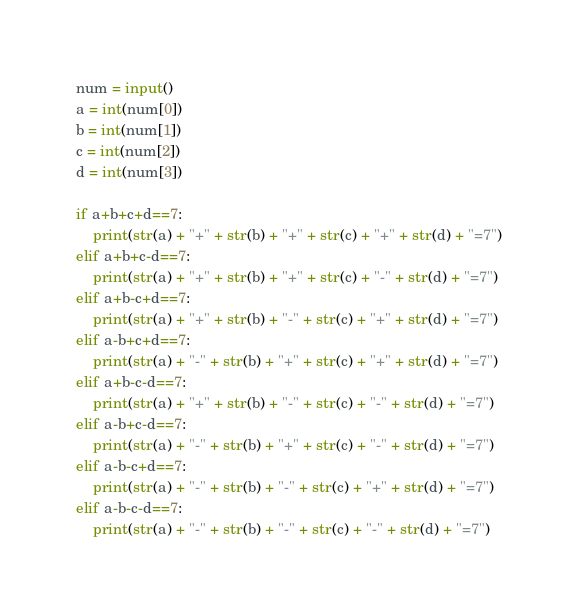<code> <loc_0><loc_0><loc_500><loc_500><_Python_>num = input()
a = int(num[0])
b = int(num[1])
c = int(num[2])
d = int(num[3])

if a+b+c+d==7:
    print(str(a) + "+" + str(b) + "+" + str(c) + "+" + str(d) + "=7")
elif a+b+c-d==7:
    print(str(a) + "+" + str(b) + "+" + str(c) + "-" + str(d) + "=7")
elif a+b-c+d==7:
    print(str(a) + "+" + str(b) + "-" + str(c) + "+" + str(d) + "=7")
elif a-b+c+d==7:
    print(str(a) + "-" + str(b) + "+" + str(c) + "+" + str(d) + "=7")
elif a+b-c-d==7:
    print(str(a) + "+" + str(b) + "-" + str(c) + "-" + str(d) + "=7")
elif a-b+c-d==7:
    print(str(a) + "-" + str(b) + "+" + str(c) + "-" + str(d) + "=7")
elif a-b-c+d==7:
    print(str(a) + "-" + str(b) + "-" + str(c) + "+" + str(d) + "=7")
elif a-b-c-d==7:
    print(str(a) + "-" + str(b) + "-" + str(c) + "-" + str(d) + "=7")</code> 